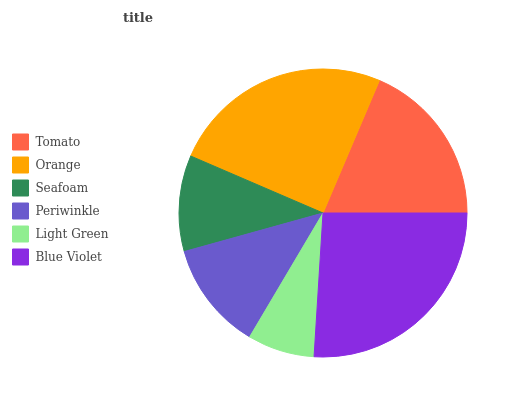Is Light Green the minimum?
Answer yes or no. Yes. Is Blue Violet the maximum?
Answer yes or no. Yes. Is Orange the minimum?
Answer yes or no. No. Is Orange the maximum?
Answer yes or no. No. Is Orange greater than Tomato?
Answer yes or no. Yes. Is Tomato less than Orange?
Answer yes or no. Yes. Is Tomato greater than Orange?
Answer yes or no. No. Is Orange less than Tomato?
Answer yes or no. No. Is Tomato the high median?
Answer yes or no. Yes. Is Periwinkle the low median?
Answer yes or no. Yes. Is Light Green the high median?
Answer yes or no. No. Is Orange the low median?
Answer yes or no. No. 